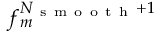Convert formula to latex. <formula><loc_0><loc_0><loc_500><loc_500>f _ { m } ^ { N _ { s m o o t h } + 1 }</formula> 